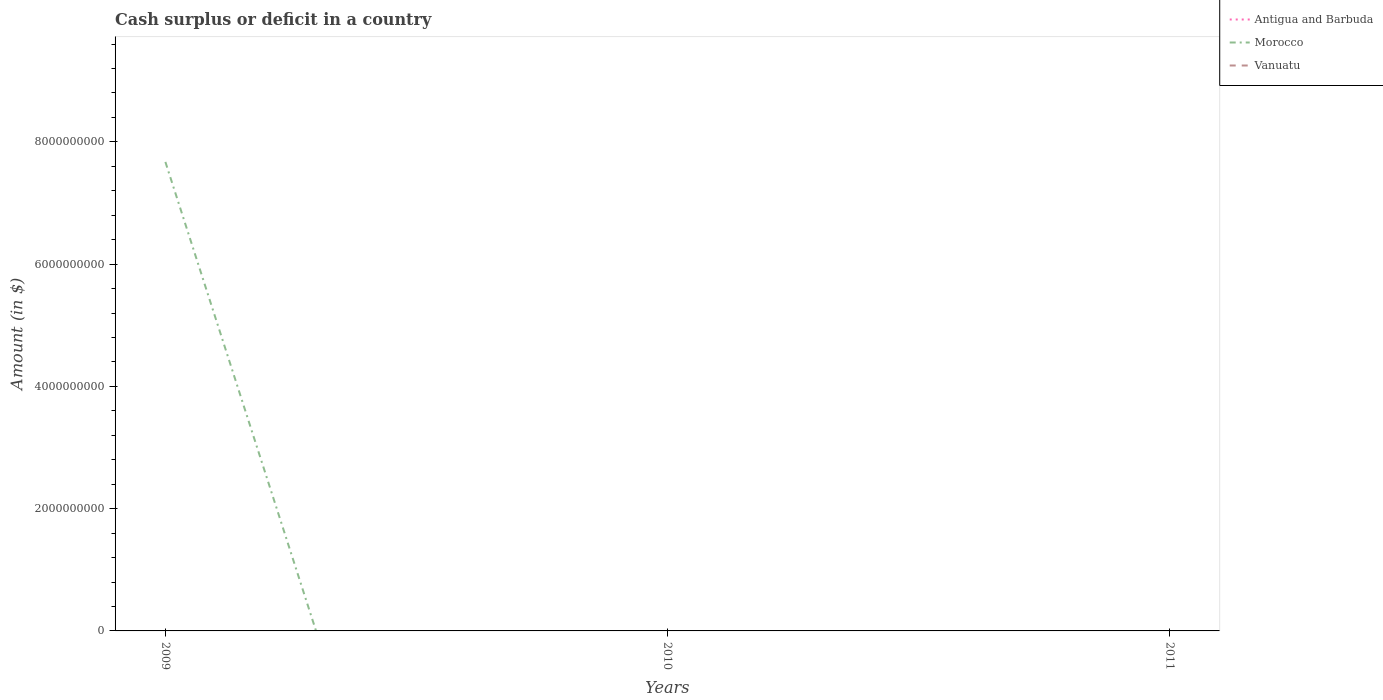Does the line corresponding to Vanuatu intersect with the line corresponding to Morocco?
Provide a short and direct response. Yes. What is the difference between the highest and the second highest amount of cash surplus or deficit in Morocco?
Provide a succinct answer. 7.67e+09. Is the amount of cash surplus or deficit in Antigua and Barbuda strictly greater than the amount of cash surplus or deficit in Vanuatu over the years?
Offer a very short reply. No. How many lines are there?
Your answer should be compact. 1. Does the graph contain any zero values?
Offer a very short reply. Yes. Does the graph contain grids?
Give a very brief answer. No. How many legend labels are there?
Your response must be concise. 3. What is the title of the graph?
Your answer should be very brief. Cash surplus or deficit in a country. What is the label or title of the X-axis?
Your answer should be very brief. Years. What is the label or title of the Y-axis?
Your answer should be compact. Amount (in $). What is the Amount (in $) of Antigua and Barbuda in 2009?
Offer a terse response. 0. What is the Amount (in $) in Morocco in 2009?
Give a very brief answer. 7.67e+09. What is the Amount (in $) in Antigua and Barbuda in 2010?
Provide a short and direct response. 0. What is the Amount (in $) of Antigua and Barbuda in 2011?
Offer a terse response. 0. What is the Amount (in $) in Vanuatu in 2011?
Provide a succinct answer. 0. Across all years, what is the maximum Amount (in $) in Morocco?
Provide a succinct answer. 7.67e+09. What is the total Amount (in $) in Morocco in the graph?
Your response must be concise. 7.67e+09. What is the total Amount (in $) of Vanuatu in the graph?
Offer a very short reply. 0. What is the average Amount (in $) in Morocco per year?
Provide a short and direct response. 2.56e+09. What is the difference between the highest and the lowest Amount (in $) in Morocco?
Keep it short and to the point. 7.67e+09. 